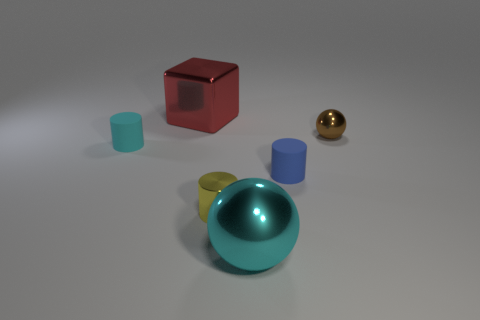How many small rubber cylinders are in front of the cyan cylinder and to the left of the shiny cylinder?
Ensure brevity in your answer.  0. Does the cyan shiny ball have the same size as the matte object that is behind the small blue rubber cylinder?
Provide a short and direct response. No. Are there any shiny objects that are on the right side of the large thing behind the cyan object that is right of the yellow object?
Your response must be concise. Yes. There is a tiny cylinder left of the big red block that is to the left of the small brown metallic ball; what is its material?
Provide a succinct answer. Rubber. What material is the thing that is behind the cyan cylinder and left of the brown sphere?
Your response must be concise. Metal. Are there any yellow things that have the same shape as the small blue object?
Your response must be concise. Yes. Are there any tiny matte cylinders on the left side of the big shiny object that is in front of the brown object?
Give a very brief answer. Yes. What number of cyan objects are the same material as the brown sphere?
Ensure brevity in your answer.  1. Are there any blue cylinders?
Your response must be concise. Yes. What number of big objects have the same color as the big sphere?
Offer a very short reply. 0. 